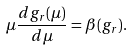Convert formula to latex. <formula><loc_0><loc_0><loc_500><loc_500>\mu \frac { d g _ { r } ( \mu ) } { d \mu } = \beta ( g _ { r } ) .</formula> 